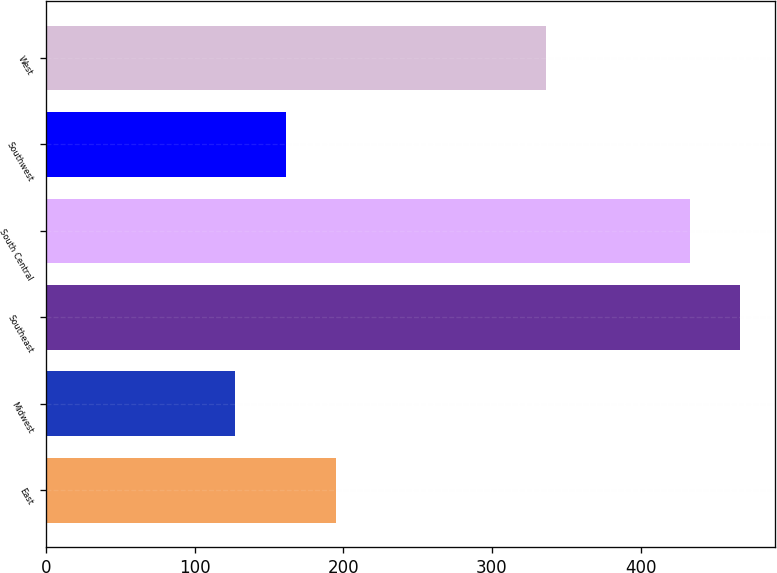Convert chart to OTSL. <chart><loc_0><loc_0><loc_500><loc_500><bar_chart><fcel>East<fcel>Midwest<fcel>Southeast<fcel>South Central<fcel>Southwest<fcel>West<nl><fcel>194.92<fcel>127.4<fcel>467.26<fcel>433.5<fcel>161.16<fcel>336.6<nl></chart> 